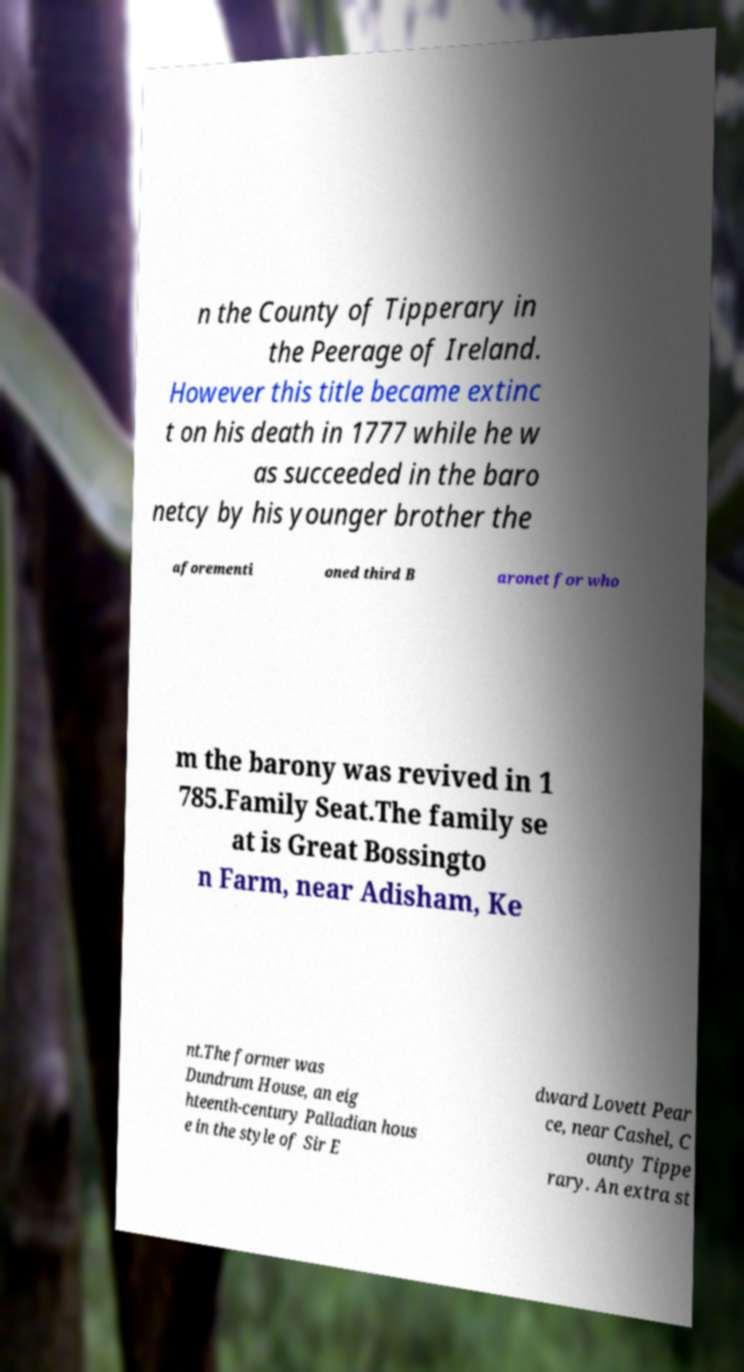What messages or text are displayed in this image? I need them in a readable, typed format. n the County of Tipperary in the Peerage of Ireland. However this title became extinc t on his death in 1777 while he w as succeeded in the baro netcy by his younger brother the aforementi oned third B aronet for who m the barony was revived in 1 785.Family Seat.The family se at is Great Bossingto n Farm, near Adisham, Ke nt.The former was Dundrum House, an eig hteenth-century Palladian hous e in the style of Sir E dward Lovett Pear ce, near Cashel, C ounty Tippe rary. An extra st 